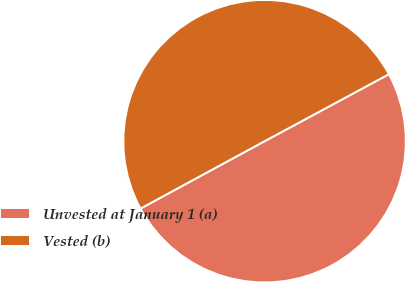Convert chart. <chart><loc_0><loc_0><loc_500><loc_500><pie_chart><fcel>Unvested at January 1 (a)<fcel>Vested (b)<nl><fcel>49.95%<fcel>50.05%<nl></chart> 